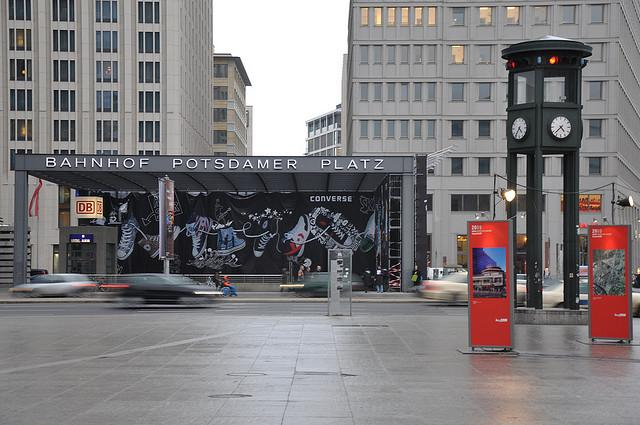One will come here if one wants to do what?

Choices:
A) order takeout
B) buy shoes
C) see movie
D) take train take train 